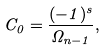<formula> <loc_0><loc_0><loc_500><loc_500>C _ { 0 } = \frac { ( - 1 ) ^ { s } } { \Omega _ { n - 1 } } ,</formula> 